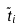Convert formula to latex. <formula><loc_0><loc_0><loc_500><loc_500>\tilde { t } _ { i }</formula> 